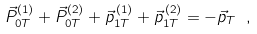<formula> <loc_0><loc_0><loc_500><loc_500>\vec { P } ^ { ( 1 ) } _ { 0 T } + \vec { P } ^ { ( 2 ) } _ { 0 T } + \vec { p } ^ { \, ( 1 ) } _ { 1 T } + \vec { p } ^ { \, ( 2 ) } _ { 1 T } = - \vec { p } _ { T } \ ,</formula> 